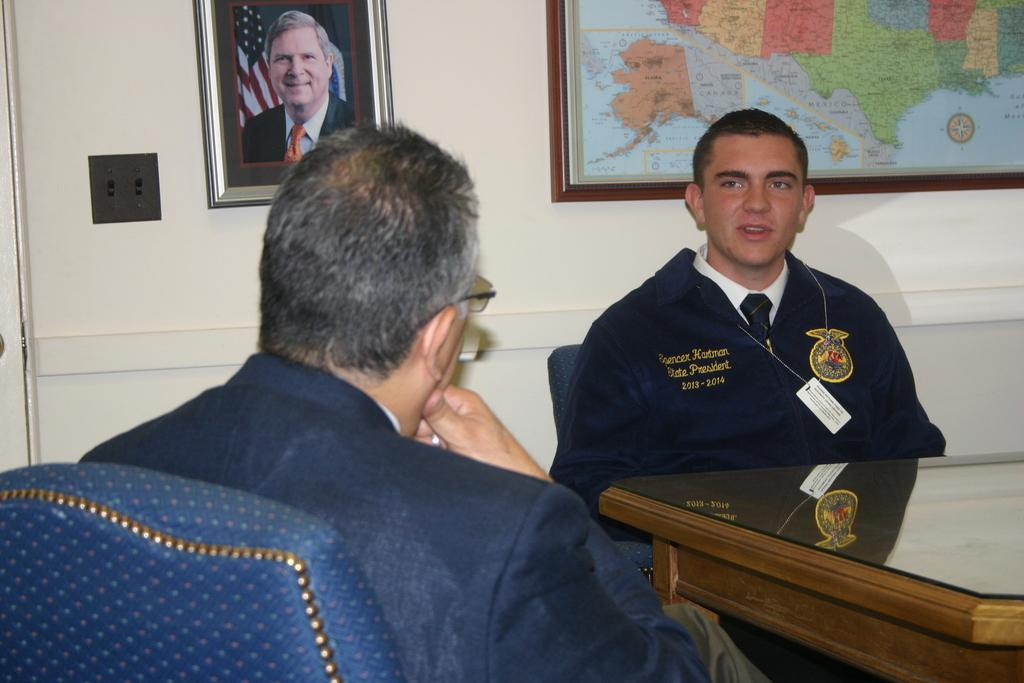How many people are present in the image? There are two people in the image. What are the two people doing? The two people are talking to each other. What is located in front of the two people? There is a table in front of the two people. What can be seen in the background of the image? There is a map and a photo frame in the background of the image. Can you tell me what the kitty is doing in the image? There is no kitty present in the image. What advice does the father give to the person in the image? There is no father or advice-giving situation depicted in the image. 